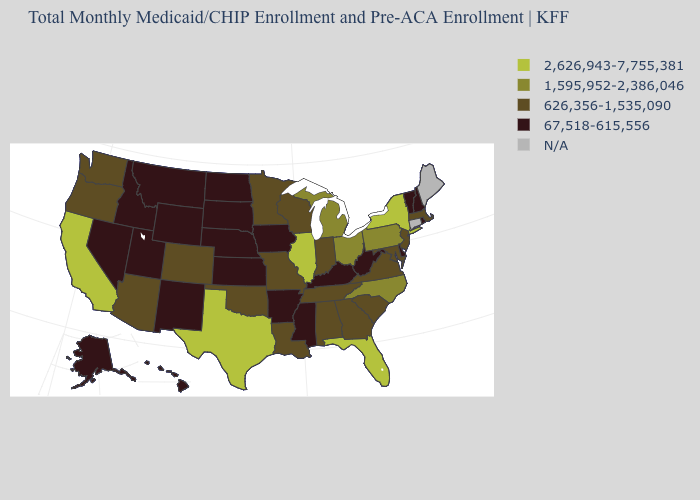Name the states that have a value in the range 626,356-1,535,090?
Short answer required. Alabama, Arizona, Colorado, Georgia, Indiana, Louisiana, Maryland, Massachusetts, Minnesota, Missouri, New Jersey, Oklahoma, Oregon, South Carolina, Tennessee, Virginia, Washington, Wisconsin. Among the states that border Colorado , which have the lowest value?
Answer briefly. Kansas, Nebraska, New Mexico, Utah, Wyoming. Among the states that border Vermont , which have the lowest value?
Short answer required. New Hampshire. Name the states that have a value in the range 626,356-1,535,090?
Quick response, please. Alabama, Arizona, Colorado, Georgia, Indiana, Louisiana, Maryland, Massachusetts, Minnesota, Missouri, New Jersey, Oklahoma, Oregon, South Carolina, Tennessee, Virginia, Washington, Wisconsin. Which states have the lowest value in the USA?
Give a very brief answer. Alaska, Arkansas, Delaware, Hawaii, Idaho, Iowa, Kansas, Kentucky, Mississippi, Montana, Nebraska, Nevada, New Hampshire, New Mexico, North Dakota, Rhode Island, South Dakota, Utah, Vermont, West Virginia, Wyoming. Does California have the highest value in the West?
Concise answer only. Yes. Among the states that border Alabama , does Mississippi have the lowest value?
Quick response, please. Yes. What is the highest value in the USA?
Be succinct. 2,626,943-7,755,381. What is the value of Mississippi?
Concise answer only. 67,518-615,556. What is the value of Connecticut?
Short answer required. N/A. Which states have the highest value in the USA?
Quick response, please. California, Florida, Illinois, New York, Texas. Does Delaware have the lowest value in the South?
Quick response, please. Yes. What is the lowest value in the South?
Give a very brief answer. 67,518-615,556. What is the highest value in the West ?
Write a very short answer. 2,626,943-7,755,381. Name the states that have a value in the range 1,595,952-2,386,046?
Be succinct. Michigan, North Carolina, Ohio, Pennsylvania. 